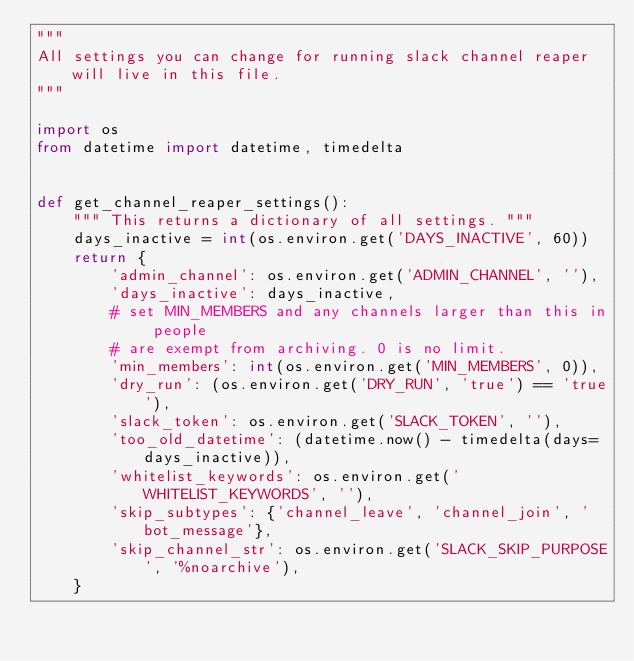<code> <loc_0><loc_0><loc_500><loc_500><_Python_>"""
All settings you can change for running slack channel reaper will live in this file.
"""

import os
from datetime import datetime, timedelta


def get_channel_reaper_settings():
    """ This returns a dictionary of all settings. """
    days_inactive = int(os.environ.get('DAYS_INACTIVE', 60))
    return {
        'admin_channel': os.environ.get('ADMIN_CHANNEL', ''),
        'days_inactive': days_inactive,
        # set MIN_MEMBERS and any channels larger than this in people
        # are exempt from archiving. 0 is no limit.
        'min_members': int(os.environ.get('MIN_MEMBERS', 0)),
        'dry_run': (os.environ.get('DRY_RUN', 'true') == 'true'),
        'slack_token': os.environ.get('SLACK_TOKEN', ''),
        'too_old_datetime': (datetime.now() - timedelta(days=days_inactive)),
        'whitelist_keywords': os.environ.get('WHITELIST_KEYWORDS', ''),
        'skip_subtypes': {'channel_leave', 'channel_join', 'bot_message'},
        'skip_channel_str': os.environ.get('SLACK_SKIP_PURPOSE', '%noarchive'),
    }
</code> 